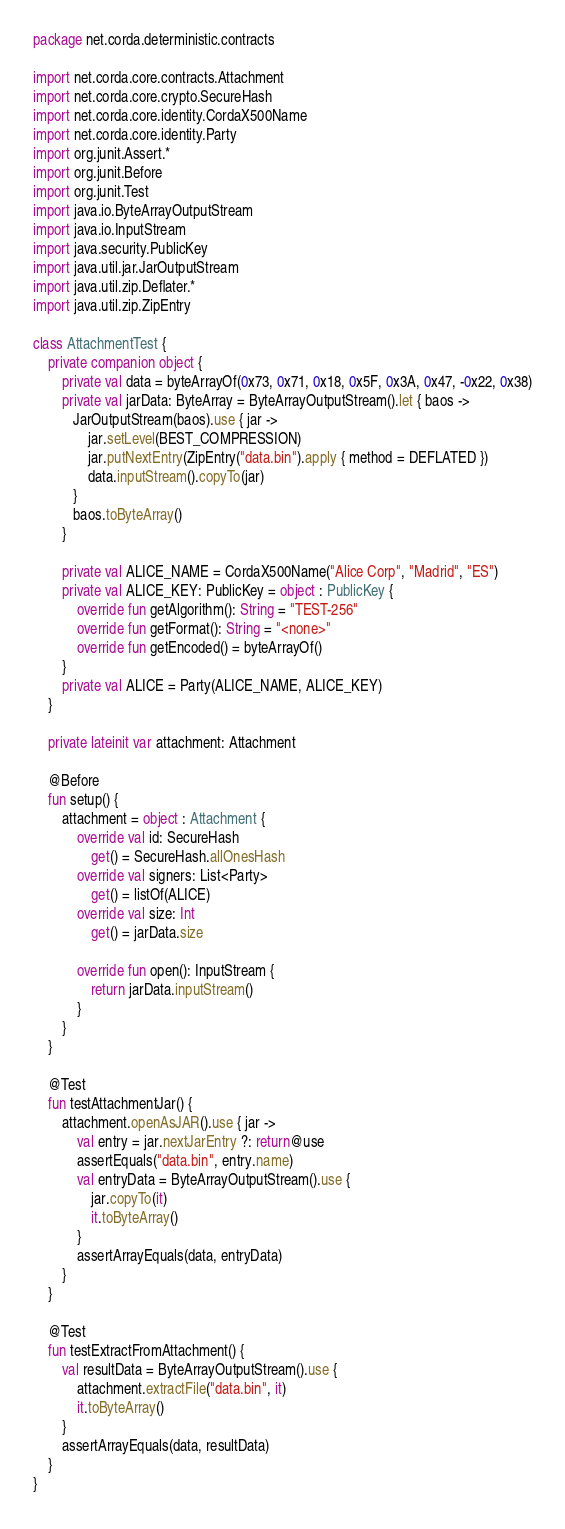<code> <loc_0><loc_0><loc_500><loc_500><_Kotlin_>package net.corda.deterministic.contracts

import net.corda.core.contracts.Attachment
import net.corda.core.crypto.SecureHash
import net.corda.core.identity.CordaX500Name
import net.corda.core.identity.Party
import org.junit.Assert.*
import org.junit.Before
import org.junit.Test
import java.io.ByteArrayOutputStream
import java.io.InputStream
import java.security.PublicKey
import java.util.jar.JarOutputStream
import java.util.zip.Deflater.*
import java.util.zip.ZipEntry

class AttachmentTest {
    private companion object {
        private val data = byteArrayOf(0x73, 0x71, 0x18, 0x5F, 0x3A, 0x47, -0x22, 0x38)
        private val jarData: ByteArray = ByteArrayOutputStream().let { baos ->
           JarOutputStream(baos).use { jar ->
               jar.setLevel(BEST_COMPRESSION)
               jar.putNextEntry(ZipEntry("data.bin").apply { method = DEFLATED })
               data.inputStream().copyTo(jar)
           }
           baos.toByteArray()
        }

        private val ALICE_NAME = CordaX500Name("Alice Corp", "Madrid", "ES")
        private val ALICE_KEY: PublicKey = object : PublicKey {
            override fun getAlgorithm(): String = "TEST-256"
            override fun getFormat(): String = "<none>"
            override fun getEncoded() = byteArrayOf()
        }
        private val ALICE = Party(ALICE_NAME, ALICE_KEY)
    }

    private lateinit var attachment: Attachment

    @Before
    fun setup() {
        attachment = object : Attachment {
            override val id: SecureHash
                get() = SecureHash.allOnesHash
            override val signers: List<Party>
                get() = listOf(ALICE)
            override val size: Int
                get() = jarData.size

            override fun open(): InputStream {
                return jarData.inputStream()
            }
        }
    }

    @Test
    fun testAttachmentJar() {
        attachment.openAsJAR().use { jar ->
            val entry = jar.nextJarEntry ?: return@use
            assertEquals("data.bin", entry.name)
            val entryData = ByteArrayOutputStream().use {
                jar.copyTo(it)
                it.toByteArray()
            }
            assertArrayEquals(data, entryData)
        }
    }

    @Test
    fun testExtractFromAttachment() {
        val resultData = ByteArrayOutputStream().use {
            attachment.extractFile("data.bin", it)
            it.toByteArray()
        }
        assertArrayEquals(data, resultData)
    }
}</code> 